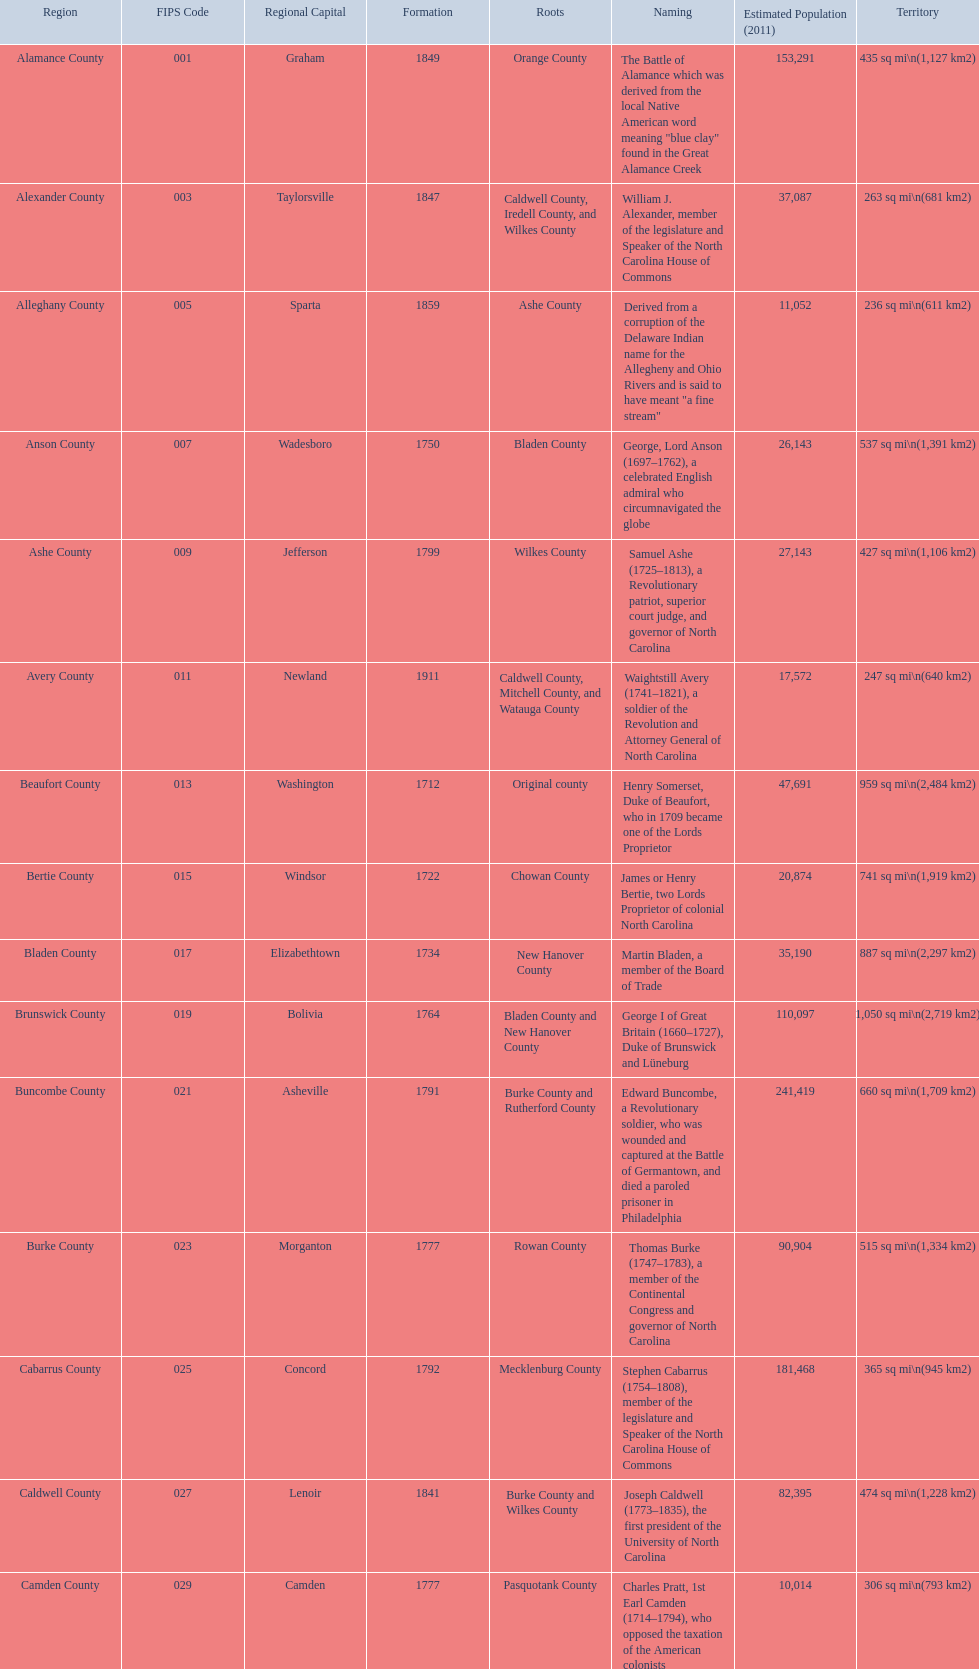Other than mecklenburg which county has the largest population? Wake County. 